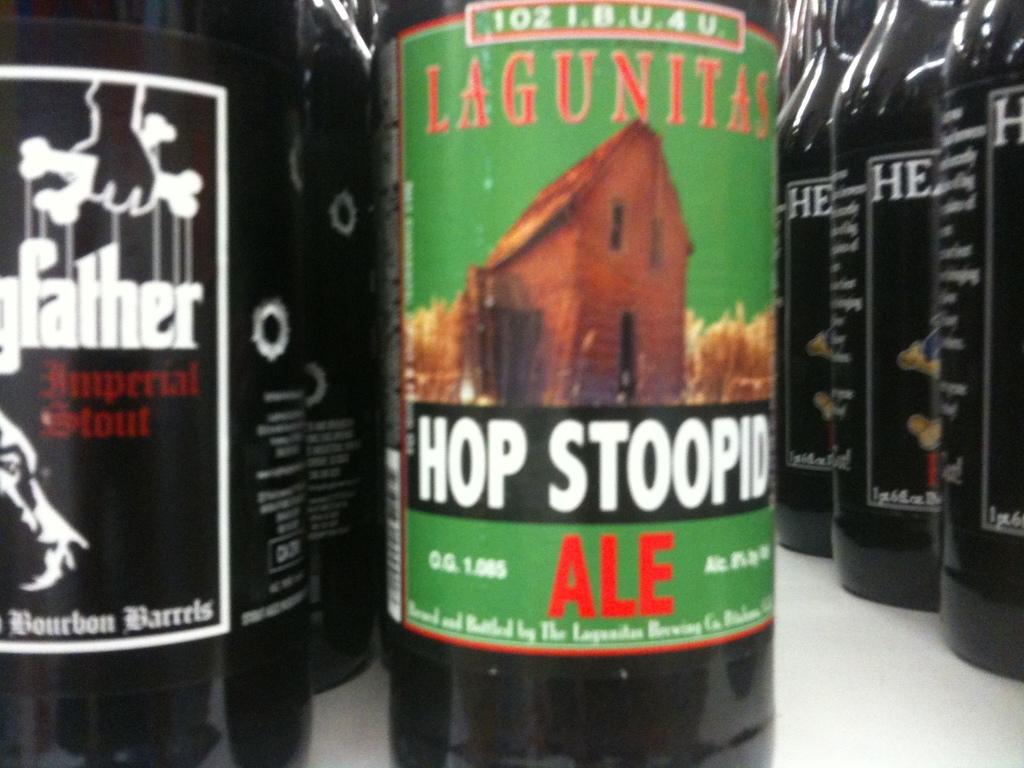What type of beer is this?
Give a very brief answer. Ale. 